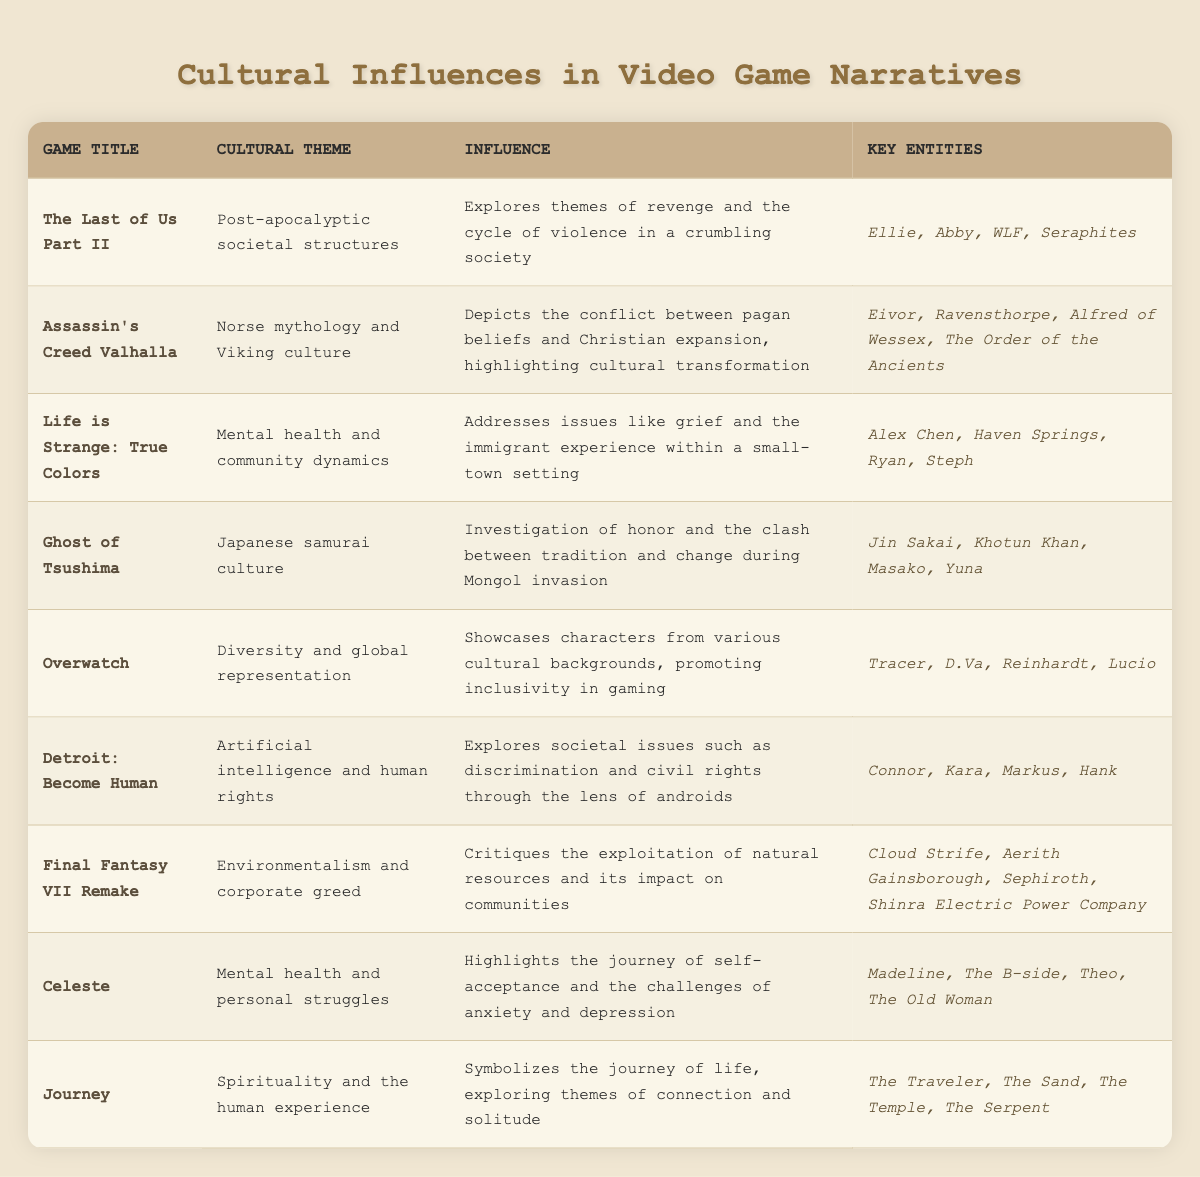What cultural theme is explored in "The Last of Us Part II"? The table lists the cultural theme for "The Last of Us Part II" as "Post-apocalyptic societal structures."
Answer: Post-apocalyptic societal structures Which game addresses issues related to mental health? "Life is Strange: True Colors" and "Celeste" both mention mental health in their cultural themes. The table identifies "Life is Strange: True Colors" as addressing mental health and community dynamics, and "Celeste" as highlighting personal struggles with mental health.
Answer: Life is Strange: True Colors and Celeste Is there a game that explores environmentalism? Yes, "Final Fantasy VII Remake" critiques environmentalism and corporate greed as indicated in the table.
Answer: Yes Which games showcase diverse characters? The table specifically mentions "Overwatch" as showcasing characters from various cultural backgrounds promoting inclusivity in gaming.
Answer: Overwatch How many key entities are associated with "Detroit: Become Human"? The table lists four key entities associated with "Detroit: Become Human": Connor, Kara, Markus, and Hank.
Answer: Four What is the influence of "Journey"? The table states that "Journey" symbolizes the journey of life, exploring themes of connection and solitude.
Answer: Connection and solitude Which game includes a character named Eivor? The table indicates that Eivor is a character in "Assassin's Creed Valhalla."
Answer: Assassin's Creed Valhalla Identify the game that discusses the clash between tradition and change. The influence of "Ghost of Tsushima" discusses the investigation of honor and the clash between tradition and change during the Mongol invasion.
Answer: Ghost of Tsushima List the games that discuss societal issues through a lens of discrimination or civil rights. "Detroit: Become Human" explores societal issues of discrimination and civil rights through the lens of androids. The table indicates this clearly.
Answer: Detroit: Become Human What is the common cultural theme between "Celeste" and "Life is Strange: True Colors"? Both games address mental health; Celeste highlights challenges of anxiety and depression, while Life is Strange addresses grief and community dynamics.
Answer: Mental health 